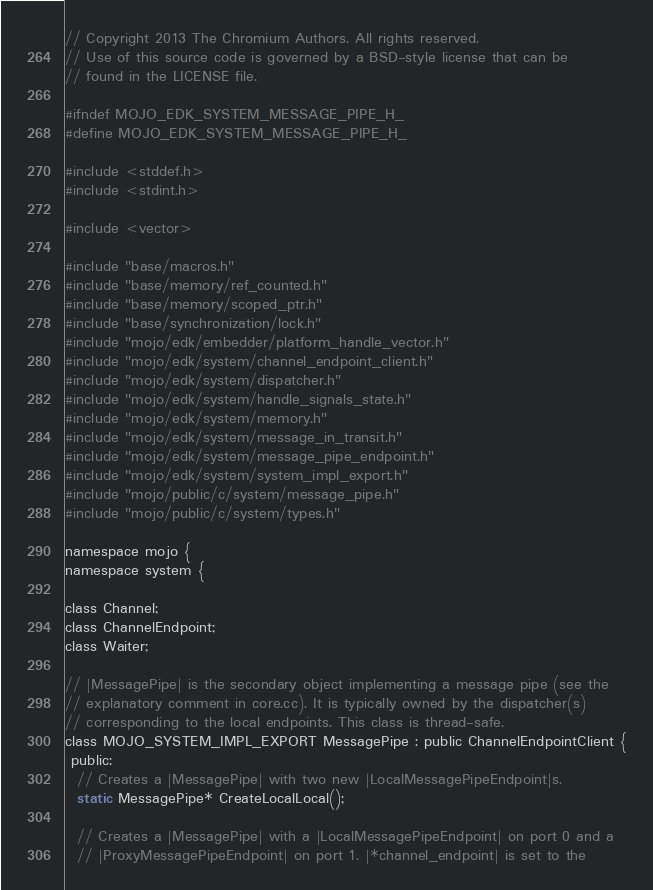<code> <loc_0><loc_0><loc_500><loc_500><_C_>// Copyright 2013 The Chromium Authors. All rights reserved.
// Use of this source code is governed by a BSD-style license that can be
// found in the LICENSE file.

#ifndef MOJO_EDK_SYSTEM_MESSAGE_PIPE_H_
#define MOJO_EDK_SYSTEM_MESSAGE_PIPE_H_

#include <stddef.h>
#include <stdint.h>

#include <vector>

#include "base/macros.h"
#include "base/memory/ref_counted.h"
#include "base/memory/scoped_ptr.h"
#include "base/synchronization/lock.h"
#include "mojo/edk/embedder/platform_handle_vector.h"
#include "mojo/edk/system/channel_endpoint_client.h"
#include "mojo/edk/system/dispatcher.h"
#include "mojo/edk/system/handle_signals_state.h"
#include "mojo/edk/system/memory.h"
#include "mojo/edk/system/message_in_transit.h"
#include "mojo/edk/system/message_pipe_endpoint.h"
#include "mojo/edk/system/system_impl_export.h"
#include "mojo/public/c/system/message_pipe.h"
#include "mojo/public/c/system/types.h"

namespace mojo {
namespace system {

class Channel;
class ChannelEndpoint;
class Waiter;

// |MessagePipe| is the secondary object implementing a message pipe (see the
// explanatory comment in core.cc). It is typically owned by the dispatcher(s)
// corresponding to the local endpoints. This class is thread-safe.
class MOJO_SYSTEM_IMPL_EXPORT MessagePipe : public ChannelEndpointClient {
 public:
  // Creates a |MessagePipe| with two new |LocalMessagePipeEndpoint|s.
  static MessagePipe* CreateLocalLocal();

  // Creates a |MessagePipe| with a |LocalMessagePipeEndpoint| on port 0 and a
  // |ProxyMessagePipeEndpoint| on port 1. |*channel_endpoint| is set to the</code> 